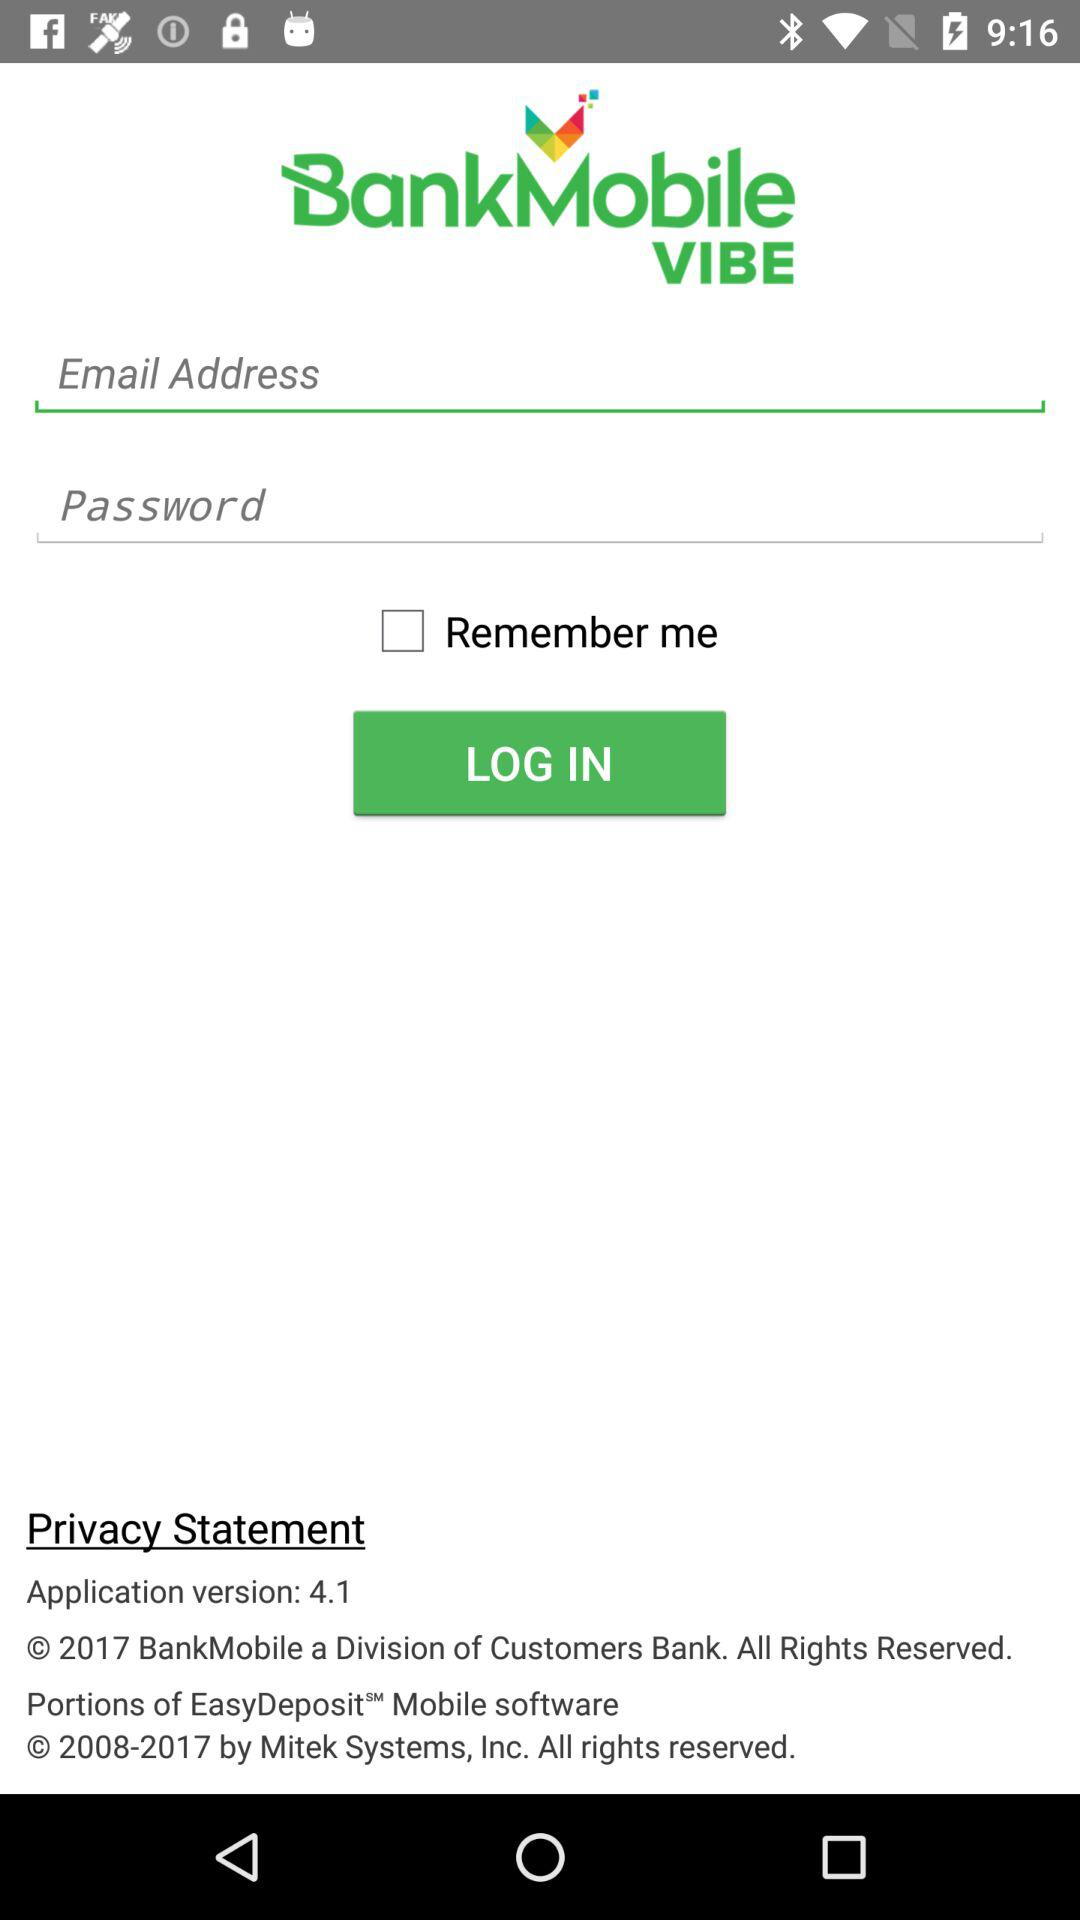What is the application version? The application version is 4.1. 